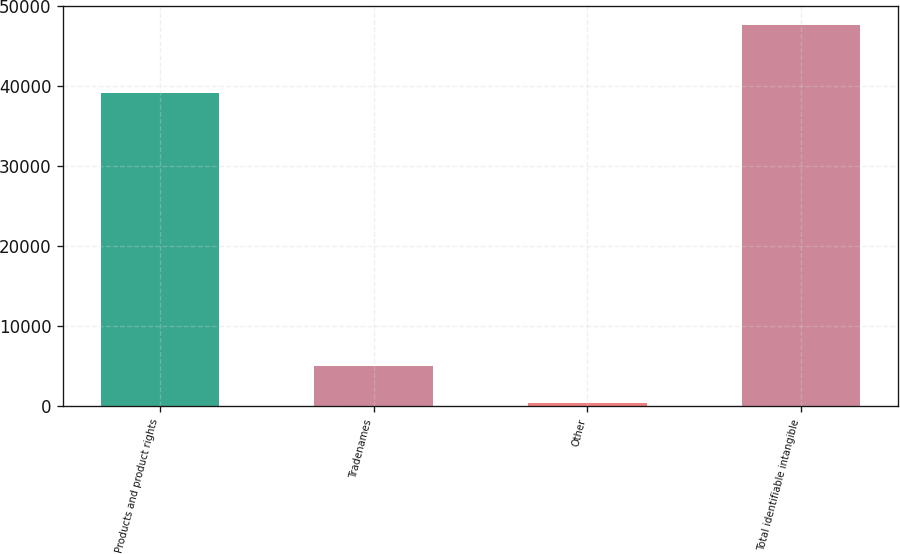Convert chart to OTSL. <chart><loc_0><loc_0><loc_500><loc_500><bar_chart><fcel>Products and product rights<fcel>Tradenames<fcel>Other<fcel>Total identifiable intangible<nl><fcel>39112.3<fcel>5076.17<fcel>345.1<fcel>47655.8<nl></chart> 